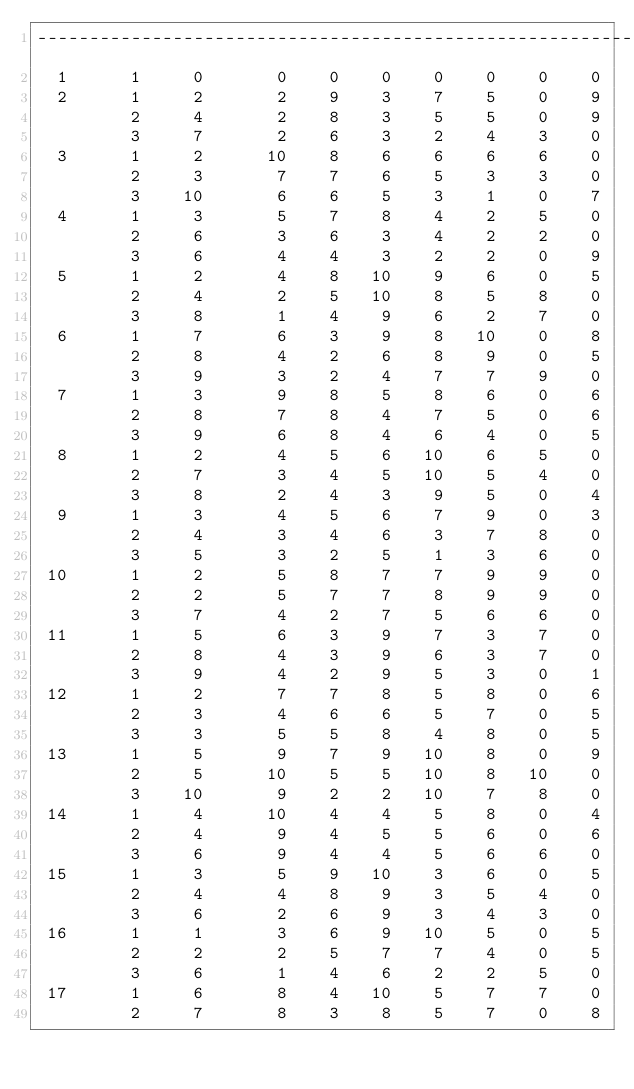Convert code to text. <code><loc_0><loc_0><loc_500><loc_500><_ObjectiveC_>------------------------------------------------------------------------
  1      1     0       0    0    0    0    0    0    0
  2      1     2       2    9    3    7    5    0    9
         2     4       2    8    3    5    5    0    9
         3     7       2    6    3    2    4    3    0
  3      1     2      10    8    6    6    6    6    0
         2     3       7    7    6    5    3    3    0
         3    10       6    6    5    3    1    0    7
  4      1     3       5    7    8    4    2    5    0
         2     6       3    6    3    4    2    2    0
         3     6       4    4    3    2    2    0    9
  5      1     2       4    8   10    9    6    0    5
         2     4       2    5   10    8    5    8    0
         3     8       1    4    9    6    2    7    0
  6      1     7       6    3    9    8   10    0    8
         2     8       4    2    6    8    9    0    5
         3     9       3    2    4    7    7    9    0
  7      1     3       9    8    5    8    6    0    6
         2     8       7    8    4    7    5    0    6
         3     9       6    8    4    6    4    0    5
  8      1     2       4    5    6   10    6    5    0
         2     7       3    4    5   10    5    4    0
         3     8       2    4    3    9    5    0    4
  9      1     3       4    5    6    7    9    0    3
         2     4       3    4    6    3    7    8    0
         3     5       3    2    5    1    3    6    0
 10      1     2       5    8    7    7    9    9    0
         2     2       5    7    7    8    9    9    0
         3     7       4    2    7    5    6    6    0
 11      1     5       6    3    9    7    3    7    0
         2     8       4    3    9    6    3    7    0
         3     9       4    2    9    5    3    0    1
 12      1     2       7    7    8    5    8    0    6
         2     3       4    6    6    5    7    0    5
         3     3       5    5    8    4    8    0    5
 13      1     5       9    7    9   10    8    0    9
         2     5      10    5    5   10    8   10    0
         3    10       9    2    2   10    7    8    0
 14      1     4      10    4    4    5    8    0    4
         2     4       9    4    5    5    6    0    6
         3     6       9    4    4    5    6    6    0
 15      1     3       5    9   10    3    6    0    5
         2     4       4    8    9    3    5    4    0
         3     6       2    6    9    3    4    3    0
 16      1     1       3    6    9   10    5    0    5
         2     2       2    5    7    7    4    0    5
         3     6       1    4    6    2    2    5    0
 17      1     6       8    4   10    5    7    7    0
         2     7       8    3    8    5    7    0    8</code> 